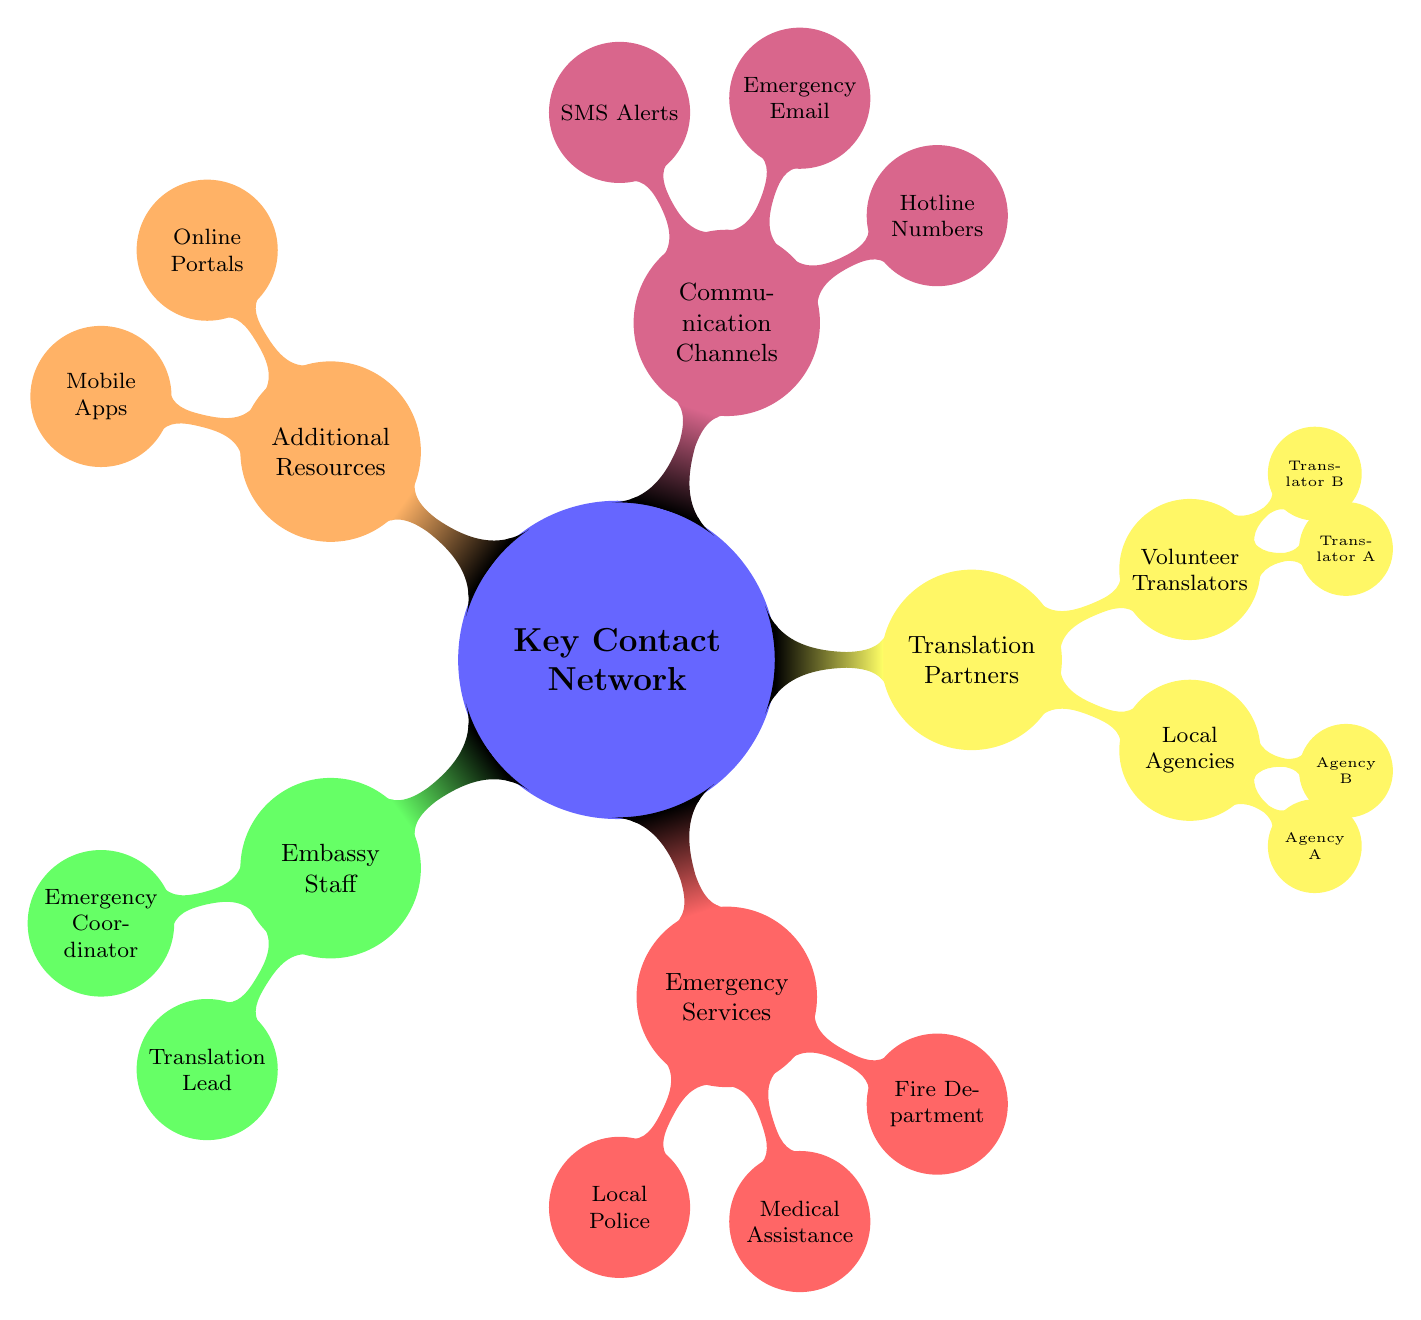What is the name of the Emergency Coordinator? The diagram shows the "Embassy Staff" section, which points to the "Emergency Coordinator" node. The text associated with this node indicates the name "John Smith."
Answer: John Smith How many agencies are listed under Local Agencies? Under "Translation Partners," the "Local Agencies" node lists "Agency A" and "Agency B." Counting these gives a total of 2 agencies.
Answer: 2 Which service corresponds to the number '987 Police Hotline'? The "Emergency Services" section lists "Local Police" as associated with the number '987 Police Hotline.' This establishes the direct link between the service and the number.
Answer: Local Police What are the two types of translation partners? In the "Translation Partners" section, there are sub-nodes for "Local Agencies" and "Volunteer Translators." These two categories represent the types of translation partners identified in the diagram.
Answer: Local Agencies, Volunteer Translators What is the purpose of the communication channel labeled as "Emergency Email"? The "Communication Channels" section includes "Emergency Email," which is used for urgent communication regarding translation services. This node outlines its specific role within the contact network.
Answer: Urgent communication Which resource is categorized under Additional Resources alongside Online Portals? The "Additional Resources" section lists two items, "Online Portals" and "Mobile Apps." The question pertains to identifying what is alongside "Online Portals," which directly refers to "Mobile Apps."
Answer: Mobile Apps Who is listed as Translator B under Volunteer Translators? In the "Translation Partners" section under "Volunteer Translators," the node labeled "Translator B" points to the name "Pedro Oliveira." This link specifies the identity of Translator B.
Answer: Pedro Oliveira What is the total number of hotline numbers provided in the diagram? The "Communication Channels" section mentions "Hotline Numbers" and lists two specific hotline numbers. Therefore, counting these hotline entries gives a total of 2 hotline numbers.
Answer: 2 Identify the translation agency corresponding to "Agency A." Under the "Local Agencies" node, "Agency A" is identified as "Global Translations Inc." This relationship directly links the agency's name with its designation as Agency A.
Answer: Global Translations Inc 